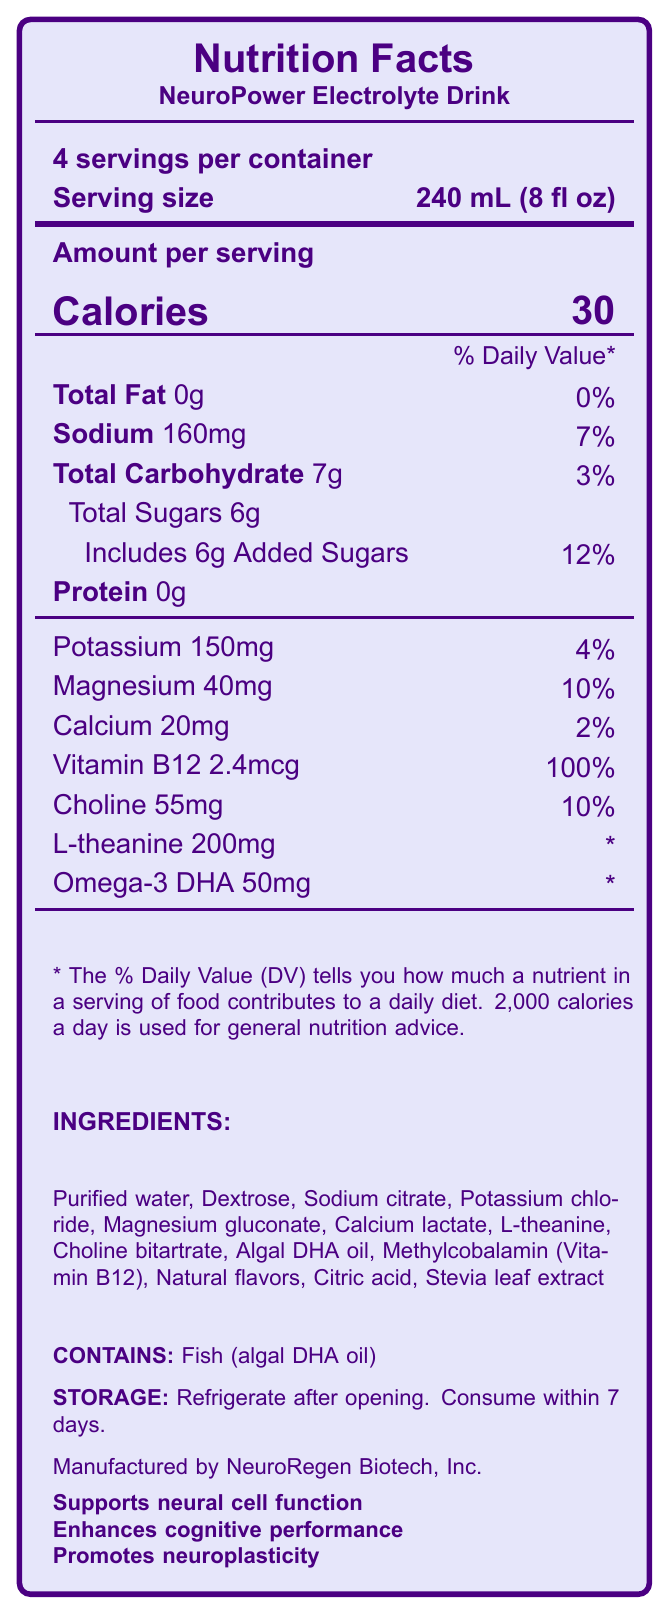what is the product name? The document specifies the product name at the top, right below the title 'Nutrition Facts'.
Answer: NeuroPower Electrolyte Drink how many servings are there per container? The information "4 servings per container" is clearly listed near the top of the document.
Answer: 4 servings what is the serving size? The serving size is specified as "240 mL (8 fl oz)" and is written near the top of the label in connection with the servings per container.
Answer: 240 mL (8 fl oz) how many calories are in each serving? The number of calories per serving is listed clearly as "30" in the "Amount per serving" section.
Answer: 30 what amount of sodium is in each serving? The amount of sodium per serving is specified as "160mg" under the "Amount per serving" section.
Answer: 160mg what percentage of the daily value of magnesium does one serving provide? The magnesium daily value is listed as "10%" for a serving size of 240 mL.
Answer: 10% which ingredients in the drink may cause allergies? The allergen information section explicitly states "Contains: Fish (algal DHA oil)".
Answer: Fish (algal DHA oil) how is the product supposed to be stored? Storage instructions clearly state to "Refrigerate after opening. Consume within 7 days."
Answer: Refrigerate after opening. Consume within 7 days. what company manufactures this product? The manufacturer is mentioned at the bottom, specified as "Manufactured by NeuroRegen Biotech, Inc."
Answer: NeuroRegen Biotech, Inc. what is the daily value percentage of added sugars in one serving? The daily value percentage for added sugars is given as "12%" for a serving size of 240 mL.
Answer: 12% what health benefits does this product claim? A. Supports neural cell function B. Enhances cognitive performance C. Promotes neuroplasticity D. All of the above The document lists the claims "Supports neural cell function," "Enhances cognitive performance," and "Promotes neuroplasticity" at the bottom of the label.
Answer: D. All of the above how much calcium is in one serving? A. 10mg B. 20mg C. 30mg D. 40mg The calcium content is listed as "20mg" under the "Amount per serving" section, with a daily value of 2%.
Answer: B. 20mg does the product contain any protein? The amount of protein is listed as "0g" in the "Amount per serving" section.
Answer: No summarize the main idea of the document. The document provides comprehensive nutritional data about the NeuroPower Electrolyte Drink. It includes details like calories, sodium, carbohydrates, sugars, protein, and specific nutrients like potassium, magnesium, calcium, Vitamin B12, choline, L-theanine, and omega-3 DHA. It also lists the ingredients, allergen information, manufacturer, and storage instructions and claims the drink supports neural cell function, enhances cognitive performance, and promotes neuroplasticity.
Answer: The document is a Nutrition Facts Label for the NeuroPower Electrolyte Drink, highlighting its serving size, nutritional content, ingredients, allergen information, storage instructions, manufacturer, and the health benefits it claims to provide. what is the percentage of daily value of Vitamin B12 in one serving? The percentage of the daily value for Vitamin B12 per serving is listed as "100%" under the "Amount per serving" section.
Answer: 100% how much omega-3 DHA is in the drink, and what is its daily value percentage? There is 50mg of omega-3 DHA in the drink, but the daily value percentage is marked with an asterisk (*), indicating that the daily value is not established.
Answer: 50mg, * how much l-theanine is present in the drink per serving? The label specifies that there are 200mg of l-theanine per serving.
Answer: 200mg can the product be consumed for more than 7 days after opening? The document states that it should be consumed within 7 days after opening, indicating it should not be consumed beyond that period.
Answer: No what is the source of Vitamin B12 in the drink? The document does not specify the source of Vitamin B12 in the drink; it only states that Vitamin B12 is included.
Answer: Not enough information 